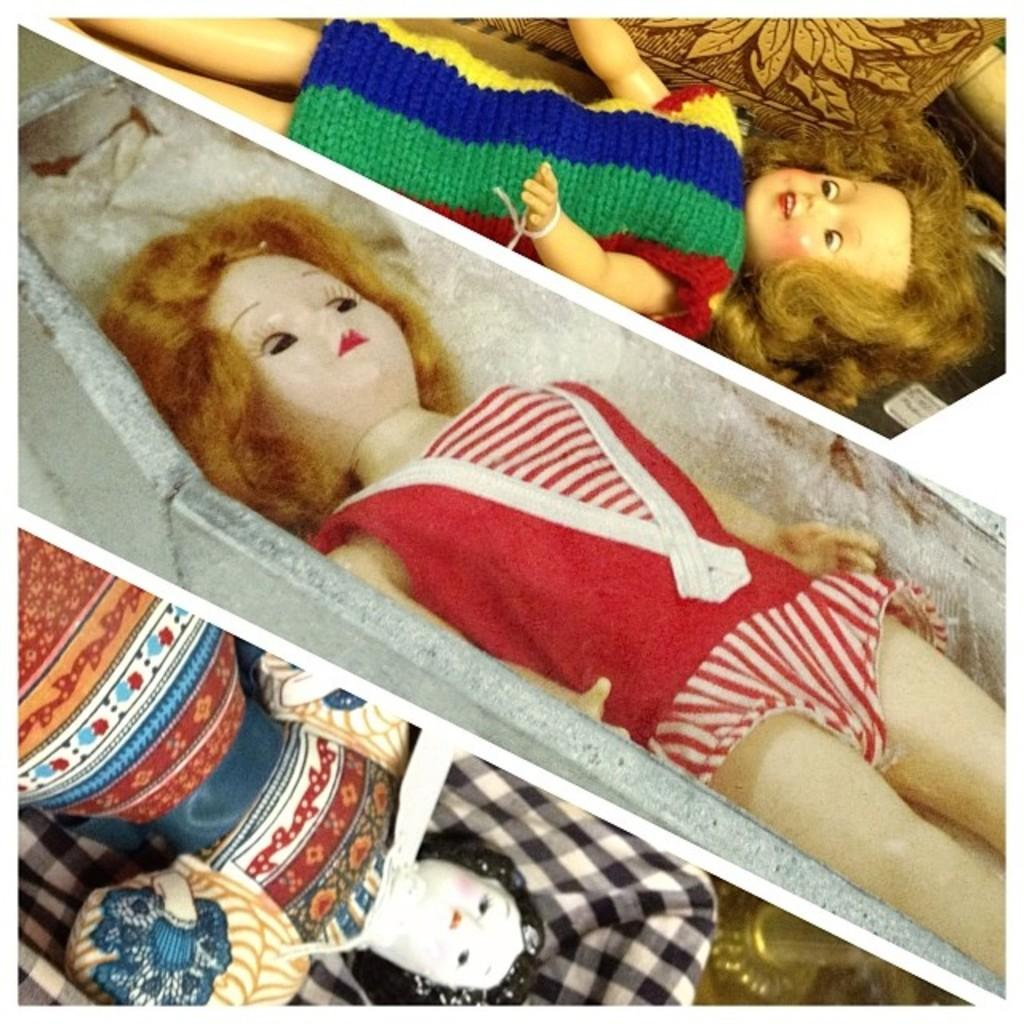How many dolls are present in the image? There are three dolls in the image. What type of objects can be seen in the image besides the dolls? There are metal objects in the image. Where is the park located in the image? There is no park present in the image. What level of expertise is required to use the metal objects in the image? The level of expertise required to use the metal objects cannot be determined from the image alone. 